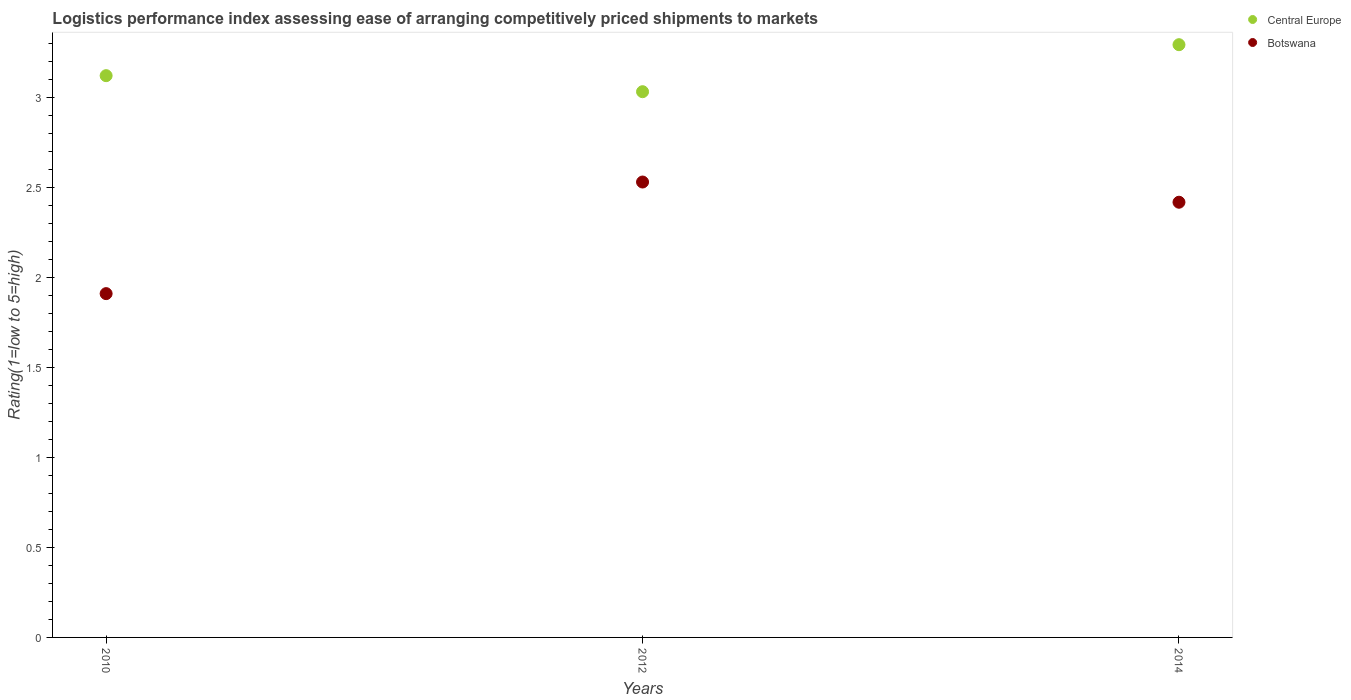How many different coloured dotlines are there?
Provide a short and direct response. 2. What is the Logistic performance index in Botswana in 2012?
Offer a very short reply. 2.53. Across all years, what is the maximum Logistic performance index in Botswana?
Ensure brevity in your answer.  2.53. Across all years, what is the minimum Logistic performance index in Botswana?
Give a very brief answer. 1.91. What is the total Logistic performance index in Botswana in the graph?
Make the answer very short. 6.86. What is the difference between the Logistic performance index in Central Europe in 2010 and that in 2012?
Make the answer very short. 0.09. What is the difference between the Logistic performance index in Central Europe in 2014 and the Logistic performance index in Botswana in 2012?
Ensure brevity in your answer.  0.76. What is the average Logistic performance index in Central Europe per year?
Your answer should be compact. 3.15. In the year 2010, what is the difference between the Logistic performance index in Central Europe and Logistic performance index in Botswana?
Your answer should be compact. 1.21. In how many years, is the Logistic performance index in Botswana greater than 1.5?
Ensure brevity in your answer.  3. What is the ratio of the Logistic performance index in Botswana in 2010 to that in 2012?
Keep it short and to the point. 0.75. Is the Logistic performance index in Central Europe in 2012 less than that in 2014?
Your answer should be compact. Yes. What is the difference between the highest and the second highest Logistic performance index in Central Europe?
Ensure brevity in your answer.  0.17. What is the difference between the highest and the lowest Logistic performance index in Botswana?
Provide a succinct answer. 0.62. Is the sum of the Logistic performance index in Botswana in 2010 and 2012 greater than the maximum Logistic performance index in Central Europe across all years?
Give a very brief answer. Yes. Is the Logistic performance index in Botswana strictly greater than the Logistic performance index in Central Europe over the years?
Provide a succinct answer. No. Is the Logistic performance index in Central Europe strictly less than the Logistic performance index in Botswana over the years?
Keep it short and to the point. No. How many dotlines are there?
Your answer should be very brief. 2. How many years are there in the graph?
Offer a very short reply. 3. Where does the legend appear in the graph?
Make the answer very short. Top right. What is the title of the graph?
Your answer should be very brief. Logistics performance index assessing ease of arranging competitively priced shipments to markets. What is the label or title of the X-axis?
Offer a terse response. Years. What is the label or title of the Y-axis?
Your answer should be very brief. Rating(1=low to 5=high). What is the Rating(1=low to 5=high) in Central Europe in 2010?
Offer a terse response. 3.12. What is the Rating(1=low to 5=high) of Botswana in 2010?
Offer a terse response. 1.91. What is the Rating(1=low to 5=high) in Central Europe in 2012?
Give a very brief answer. 3.03. What is the Rating(1=low to 5=high) of Botswana in 2012?
Keep it short and to the point. 2.53. What is the Rating(1=low to 5=high) in Central Europe in 2014?
Make the answer very short. 3.29. What is the Rating(1=low to 5=high) of Botswana in 2014?
Ensure brevity in your answer.  2.42. Across all years, what is the maximum Rating(1=low to 5=high) in Central Europe?
Make the answer very short. 3.29. Across all years, what is the maximum Rating(1=low to 5=high) in Botswana?
Offer a terse response. 2.53. Across all years, what is the minimum Rating(1=low to 5=high) of Central Europe?
Ensure brevity in your answer.  3.03. Across all years, what is the minimum Rating(1=low to 5=high) of Botswana?
Offer a very short reply. 1.91. What is the total Rating(1=low to 5=high) in Central Europe in the graph?
Your answer should be very brief. 9.45. What is the total Rating(1=low to 5=high) in Botswana in the graph?
Your answer should be very brief. 6.86. What is the difference between the Rating(1=low to 5=high) in Central Europe in 2010 and that in 2012?
Give a very brief answer. 0.09. What is the difference between the Rating(1=low to 5=high) in Botswana in 2010 and that in 2012?
Keep it short and to the point. -0.62. What is the difference between the Rating(1=low to 5=high) in Central Europe in 2010 and that in 2014?
Give a very brief answer. -0.17. What is the difference between the Rating(1=low to 5=high) in Botswana in 2010 and that in 2014?
Your answer should be very brief. -0.51. What is the difference between the Rating(1=low to 5=high) in Central Europe in 2012 and that in 2014?
Make the answer very short. -0.26. What is the difference between the Rating(1=low to 5=high) in Botswana in 2012 and that in 2014?
Offer a terse response. 0.11. What is the difference between the Rating(1=low to 5=high) in Central Europe in 2010 and the Rating(1=low to 5=high) in Botswana in 2012?
Your response must be concise. 0.59. What is the difference between the Rating(1=low to 5=high) of Central Europe in 2010 and the Rating(1=low to 5=high) of Botswana in 2014?
Your answer should be very brief. 0.7. What is the difference between the Rating(1=low to 5=high) in Central Europe in 2012 and the Rating(1=low to 5=high) in Botswana in 2014?
Provide a succinct answer. 0.61. What is the average Rating(1=low to 5=high) in Central Europe per year?
Ensure brevity in your answer.  3.15. What is the average Rating(1=low to 5=high) of Botswana per year?
Keep it short and to the point. 2.29. In the year 2010, what is the difference between the Rating(1=low to 5=high) of Central Europe and Rating(1=low to 5=high) of Botswana?
Your answer should be compact. 1.21. In the year 2012, what is the difference between the Rating(1=low to 5=high) of Central Europe and Rating(1=low to 5=high) of Botswana?
Make the answer very short. 0.5. In the year 2014, what is the difference between the Rating(1=low to 5=high) in Central Europe and Rating(1=low to 5=high) in Botswana?
Provide a short and direct response. 0.88. What is the ratio of the Rating(1=low to 5=high) of Central Europe in 2010 to that in 2012?
Keep it short and to the point. 1.03. What is the ratio of the Rating(1=low to 5=high) of Botswana in 2010 to that in 2012?
Keep it short and to the point. 0.75. What is the ratio of the Rating(1=low to 5=high) in Central Europe in 2010 to that in 2014?
Offer a terse response. 0.95. What is the ratio of the Rating(1=low to 5=high) in Botswana in 2010 to that in 2014?
Provide a short and direct response. 0.79. What is the ratio of the Rating(1=low to 5=high) of Central Europe in 2012 to that in 2014?
Your answer should be very brief. 0.92. What is the ratio of the Rating(1=low to 5=high) in Botswana in 2012 to that in 2014?
Provide a short and direct response. 1.05. What is the difference between the highest and the second highest Rating(1=low to 5=high) of Central Europe?
Keep it short and to the point. 0.17. What is the difference between the highest and the second highest Rating(1=low to 5=high) in Botswana?
Provide a short and direct response. 0.11. What is the difference between the highest and the lowest Rating(1=low to 5=high) of Central Europe?
Make the answer very short. 0.26. What is the difference between the highest and the lowest Rating(1=low to 5=high) of Botswana?
Offer a terse response. 0.62. 